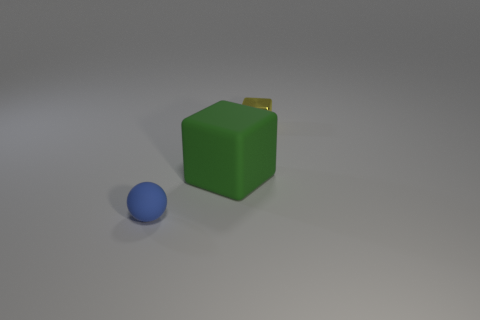Add 3 large things. How many objects exist? 6 Subtract all yellow cubes. How many cubes are left? 1 Subtract 2 blocks. How many blocks are left? 0 Subtract all balls. How many objects are left? 2 Subtract 0 cyan cubes. How many objects are left? 3 Subtract all yellow blocks. Subtract all purple cylinders. How many blocks are left? 1 Subtract all large green matte objects. Subtract all big green matte things. How many objects are left? 1 Add 3 large green matte objects. How many large green matte objects are left? 4 Add 1 yellow metal objects. How many yellow metal objects exist? 2 